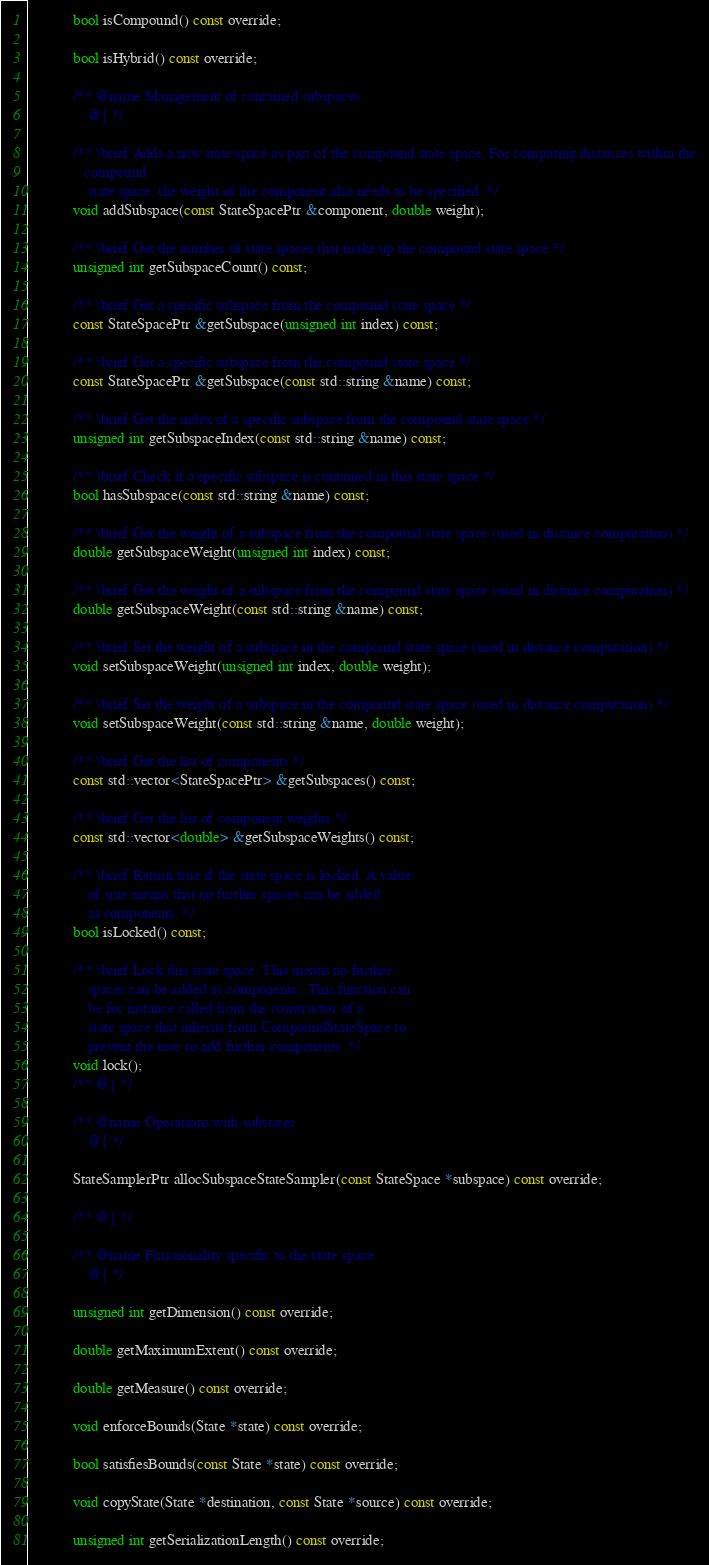<code> <loc_0><loc_0><loc_500><loc_500><_C_>            bool isCompound() const override;

            bool isHybrid() const override;

            /** @name Management of contained subspaces
                @{ */

            /** \brief Adds a new state space as part of the compound state space. For computing distances within the
               compound
                state space, the weight of the component also needs to be specified. */
            void addSubspace(const StateSpacePtr &component, double weight);

            /** \brief Get the number of state spaces that make up the compound state space */
            unsigned int getSubspaceCount() const;

            /** \brief Get a specific subspace from the compound state space */
            const StateSpacePtr &getSubspace(unsigned int index) const;

            /** \brief Get a specific subspace from the compound state space */
            const StateSpacePtr &getSubspace(const std::string &name) const;

            /** \brief Get the index of a specific subspace from the compound state space */
            unsigned int getSubspaceIndex(const std::string &name) const;

            /** \brief Check if a specific subspace is contained in this state space */
            bool hasSubspace(const std::string &name) const;

            /** \brief Get the weight of a subspace from the compound state space (used in distance computation) */
            double getSubspaceWeight(unsigned int index) const;

            /** \brief Get the weight of a subspace from the compound state space (used in distance computation) */
            double getSubspaceWeight(const std::string &name) const;

            /** \brief Set the weight of a subspace in the compound state space (used in distance computation) */
            void setSubspaceWeight(unsigned int index, double weight);

            /** \brief Set the weight of a subspace in the compound state space (used in distance computation) */
            void setSubspaceWeight(const std::string &name, double weight);

            /** \brief Get the list of components */
            const std::vector<StateSpacePtr> &getSubspaces() const;

            /** \brief Get the list of component weights */
            const std::vector<double> &getSubspaceWeights() const;

            /** \brief Return true if the state space is locked. A value
                of true means that no further spaces can be added
                as components. */
            bool isLocked() const;

            /** \brief Lock this state space. This means no further
                spaces can be added as components.  This function can
                be for instance called from the constructor of a
                state space that inherits from CompoundStateSpace to
                prevent the user to add further components. */
            void lock();
            /** @} */

            /** @name Operations with substates
                @{ */

            StateSamplerPtr allocSubspaceStateSampler(const StateSpace *subspace) const override;

            /** @} */

            /** @name Functionality specific to the state space
                @{ */

            unsigned int getDimension() const override;

            double getMaximumExtent() const override;

            double getMeasure() const override;

            void enforceBounds(State *state) const override;

            bool satisfiesBounds(const State *state) const override;

            void copyState(State *destination, const State *source) const override;

            unsigned int getSerializationLength() const override;
</code> 